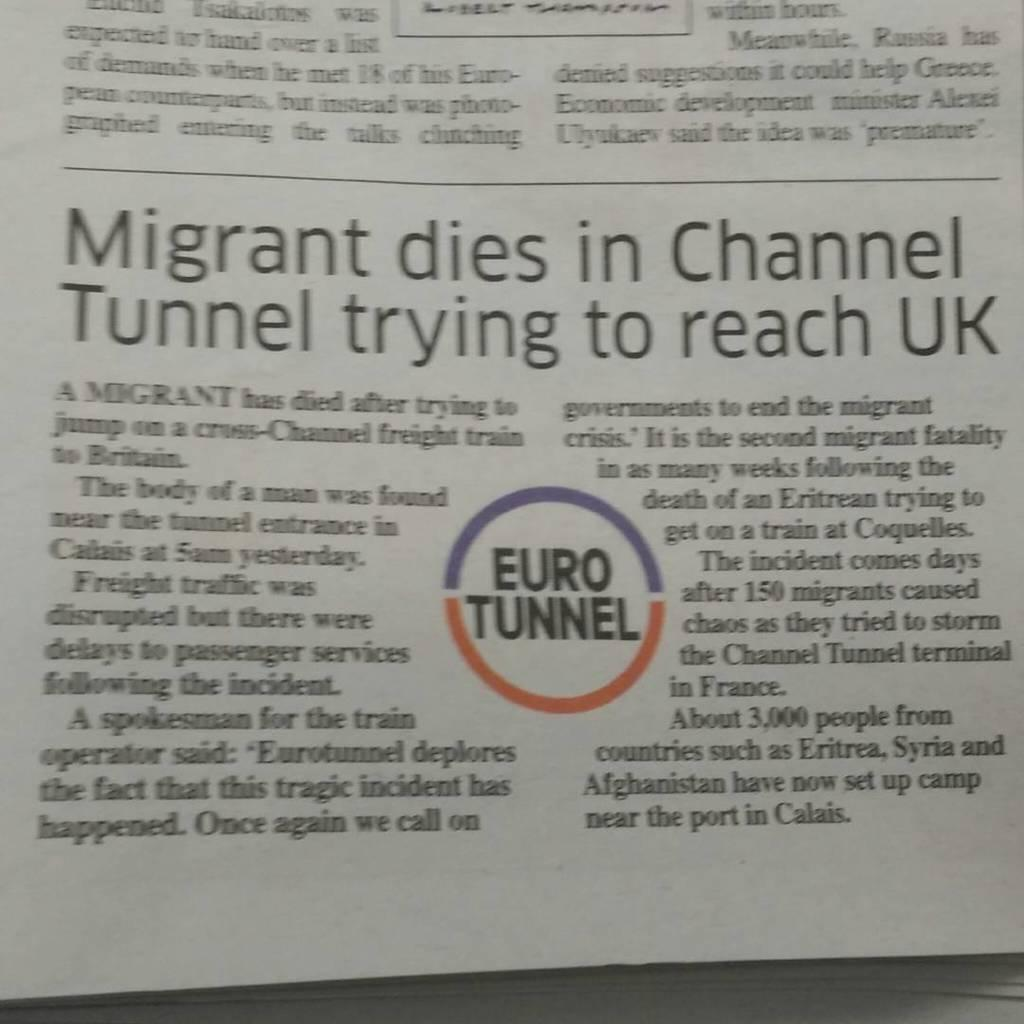Provide a one-sentence caption for the provided image. A photo of a British newspaper story about a migrant dying in the Channel Tunnel. 